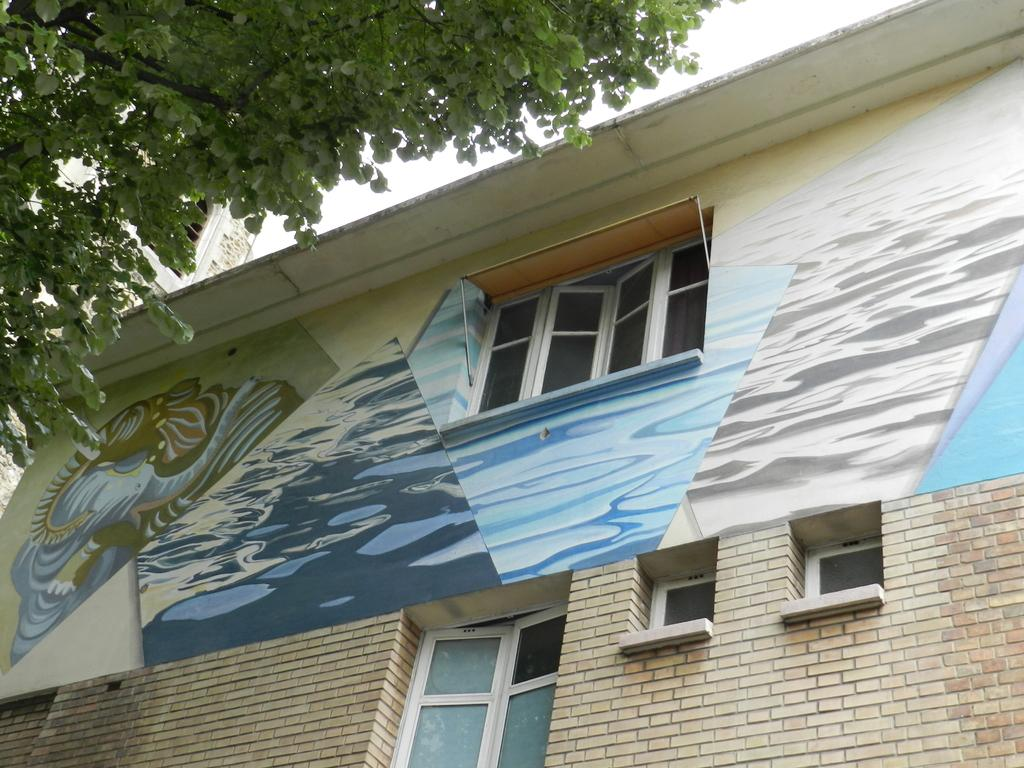What is depicted on the building in the image? There is a painting on a building in the image. What feature of the building is mentioned in the facts? The building has windows. What can be seen in front of the building? There is a tree in front of the building. What type of collar can be seen on the maid in the image? There is no maid or collar present in the image. What scene is depicted in the painting on the building? The facts provided do not give enough information to determine the scene depicted in the painting on the building. 